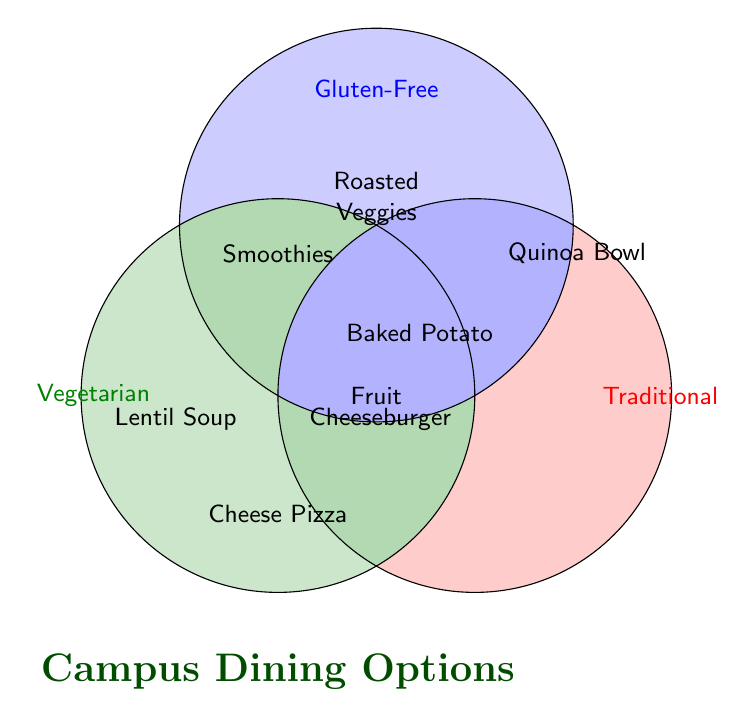What's the title of the figure? The title is usually the largest text at the top or bottom of the figure. In this case, it is at the bottom and says "Campus Dining Options"
Answer: Campus Dining Options How many categories are represented in the Venn Diagram? The categories are delineated by the three labeled circles. The labels are "Vegetarian," "Gluten-Free," and "Traditional". So, there are three categories in total
Answer: Three Which items are both Vegetarian and Gluten-Free? To find items in both categories, look at the overlap of the "Vegetarian" and "Gluten-Free" circles. The items listed there are "Roasted Vegetable Medley" and "Fruit Smoothies"
Answer: Roasted Vegetable Medley and Fruit Smoothies What item is shared by all three categories? The item that is located at the intersection of all three circles is the one shared by all categories. It is labeled "Fruit"
Answer: Fresh Fruit Selection What is unique to the Traditional category? Look for the items located solely within the "Traditional" circle without overlapping the other circles. These are "Cheeseburger," "Pizza," and "Spaghetti and Meatballs"
Answer: Cheeseburger, Pizza, and Spaghetti and Meatballs How many items are Vegetarian but not Gluten-Free or Traditional? Find the items within the "Vegetarian" circle that do not overlap with the other circles. These are "Lentil Soup," "Garden Salad Bar," and "Grilled Portobello Sandwich"
Answer: Three Compare the number of items exclusive to Gluten-Free vs. those shared by Gluten-Free and Traditional Count the items exclusively in the "Gluten-Free" circle: "Quinoa Bowl," "Grilled Chicken Breast," and "Rice Noodle Stir-Fry" (3 items). Count the items where "Gluten-Free" and "Traditional" overlap: "Baked Potato Bar" (1 item). So, there are more items exclusive to Gluten-Free than shared by Gluten-Free and Traditional
Answer: Exclusively Gluten-Free has more What is located at the intersection of Vegetarian and Traditional categories? Look at the overlap between the "Vegetarian" and "Traditional" circles. The items there are "Cheese Pizza"
Answer: Cheese Pizza How many items are Gluten-Free but not Vegetarian? Look for the items in the "Gluten-Free" circle that do not overlap with the "Vegetarian" circle. These are "Quinoa Bowl," "Grilled Chicken Breast," "Rice Noodle Stir-Fry," and "Baked Potato Bar". Since "Baked Potato Bar" is shared with Traditional, it's not counted
Answer: Three Which category does the "Baked Potato Bar" belong to? Look at the position of the "Baked Potato Bar" on the diagram. It is located in the intersection of the "Gluten-Free" and "Traditional" circles
Answer: Gluten-Free and Traditional 